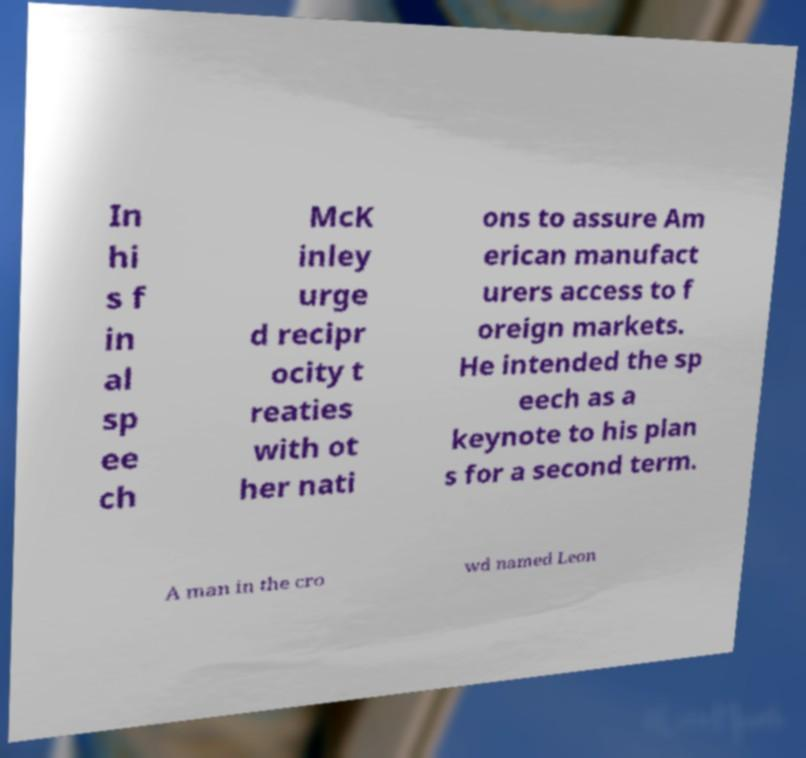Could you assist in decoding the text presented in this image and type it out clearly? In hi s f in al sp ee ch McK inley urge d recipr ocity t reaties with ot her nati ons to assure Am erican manufact urers access to f oreign markets. He intended the sp eech as a keynote to his plan s for a second term. A man in the cro wd named Leon 